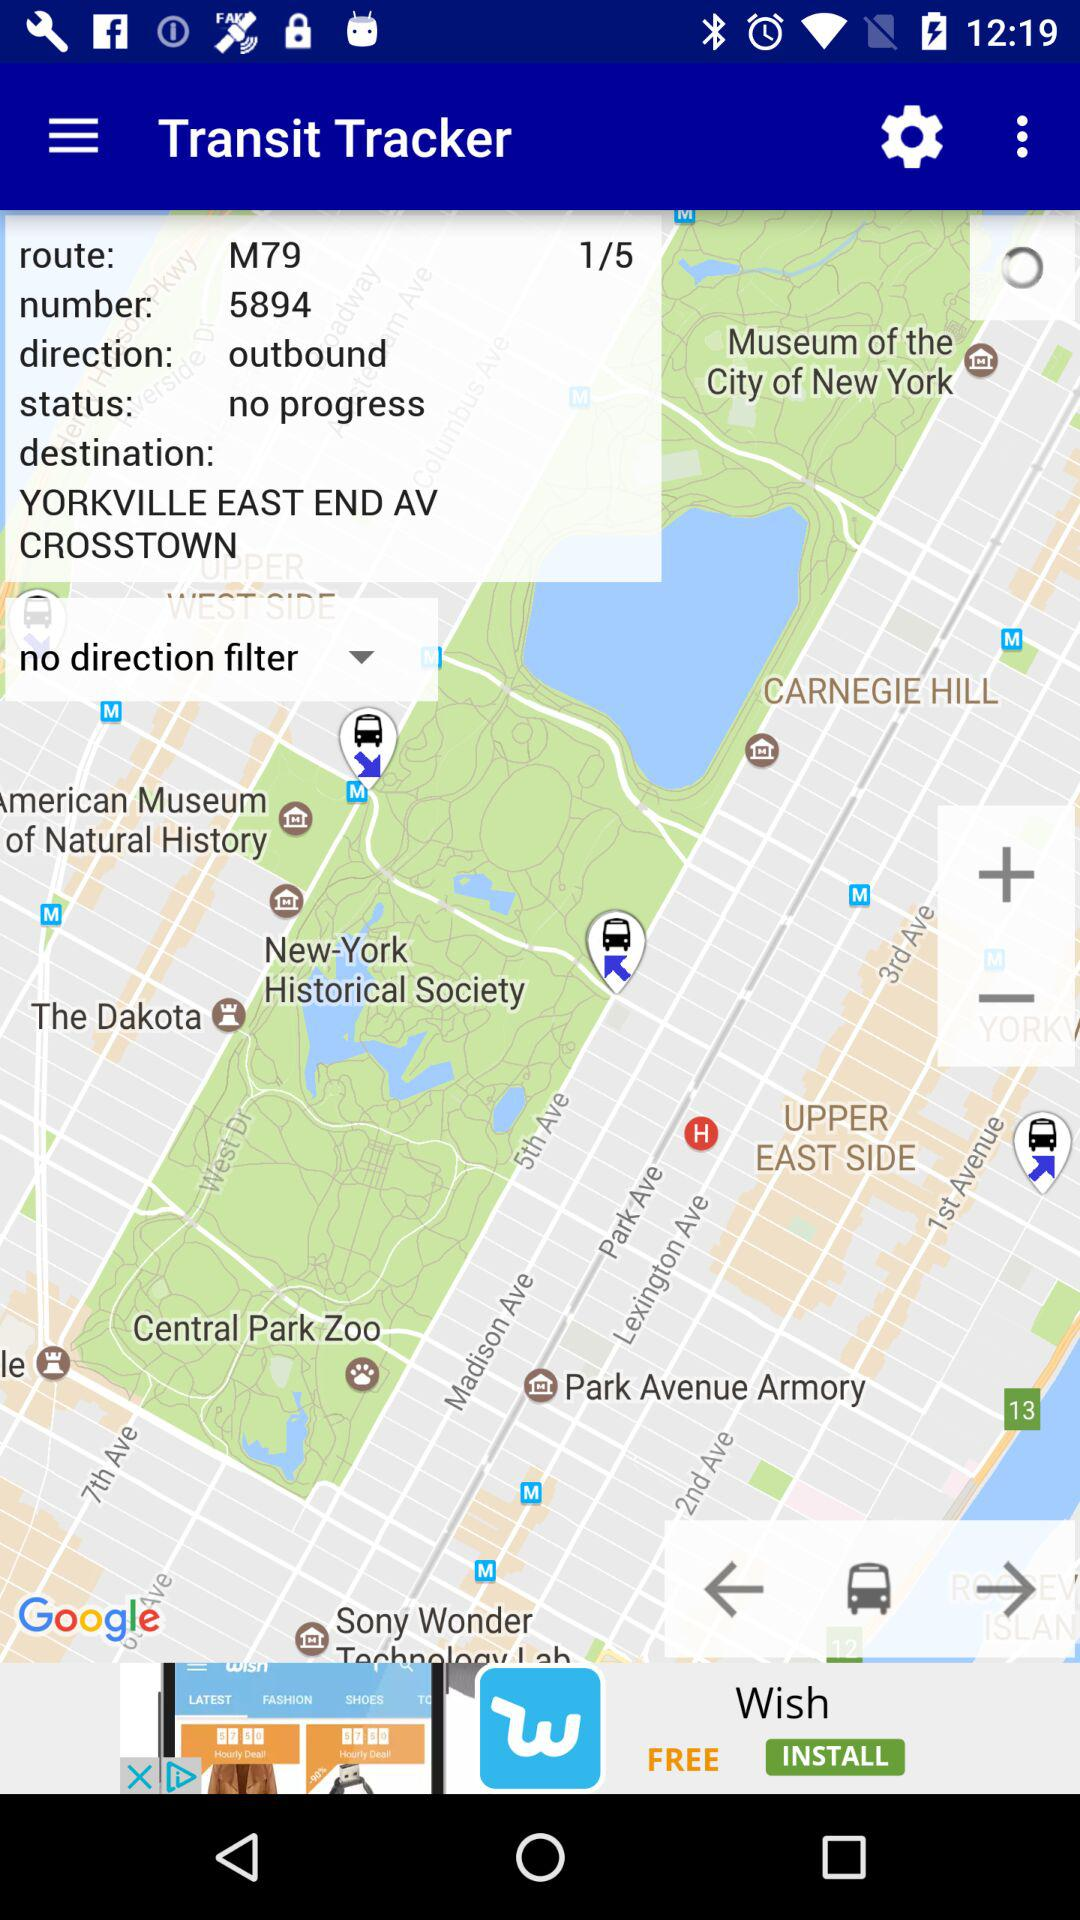What's the route? The route is M79. 